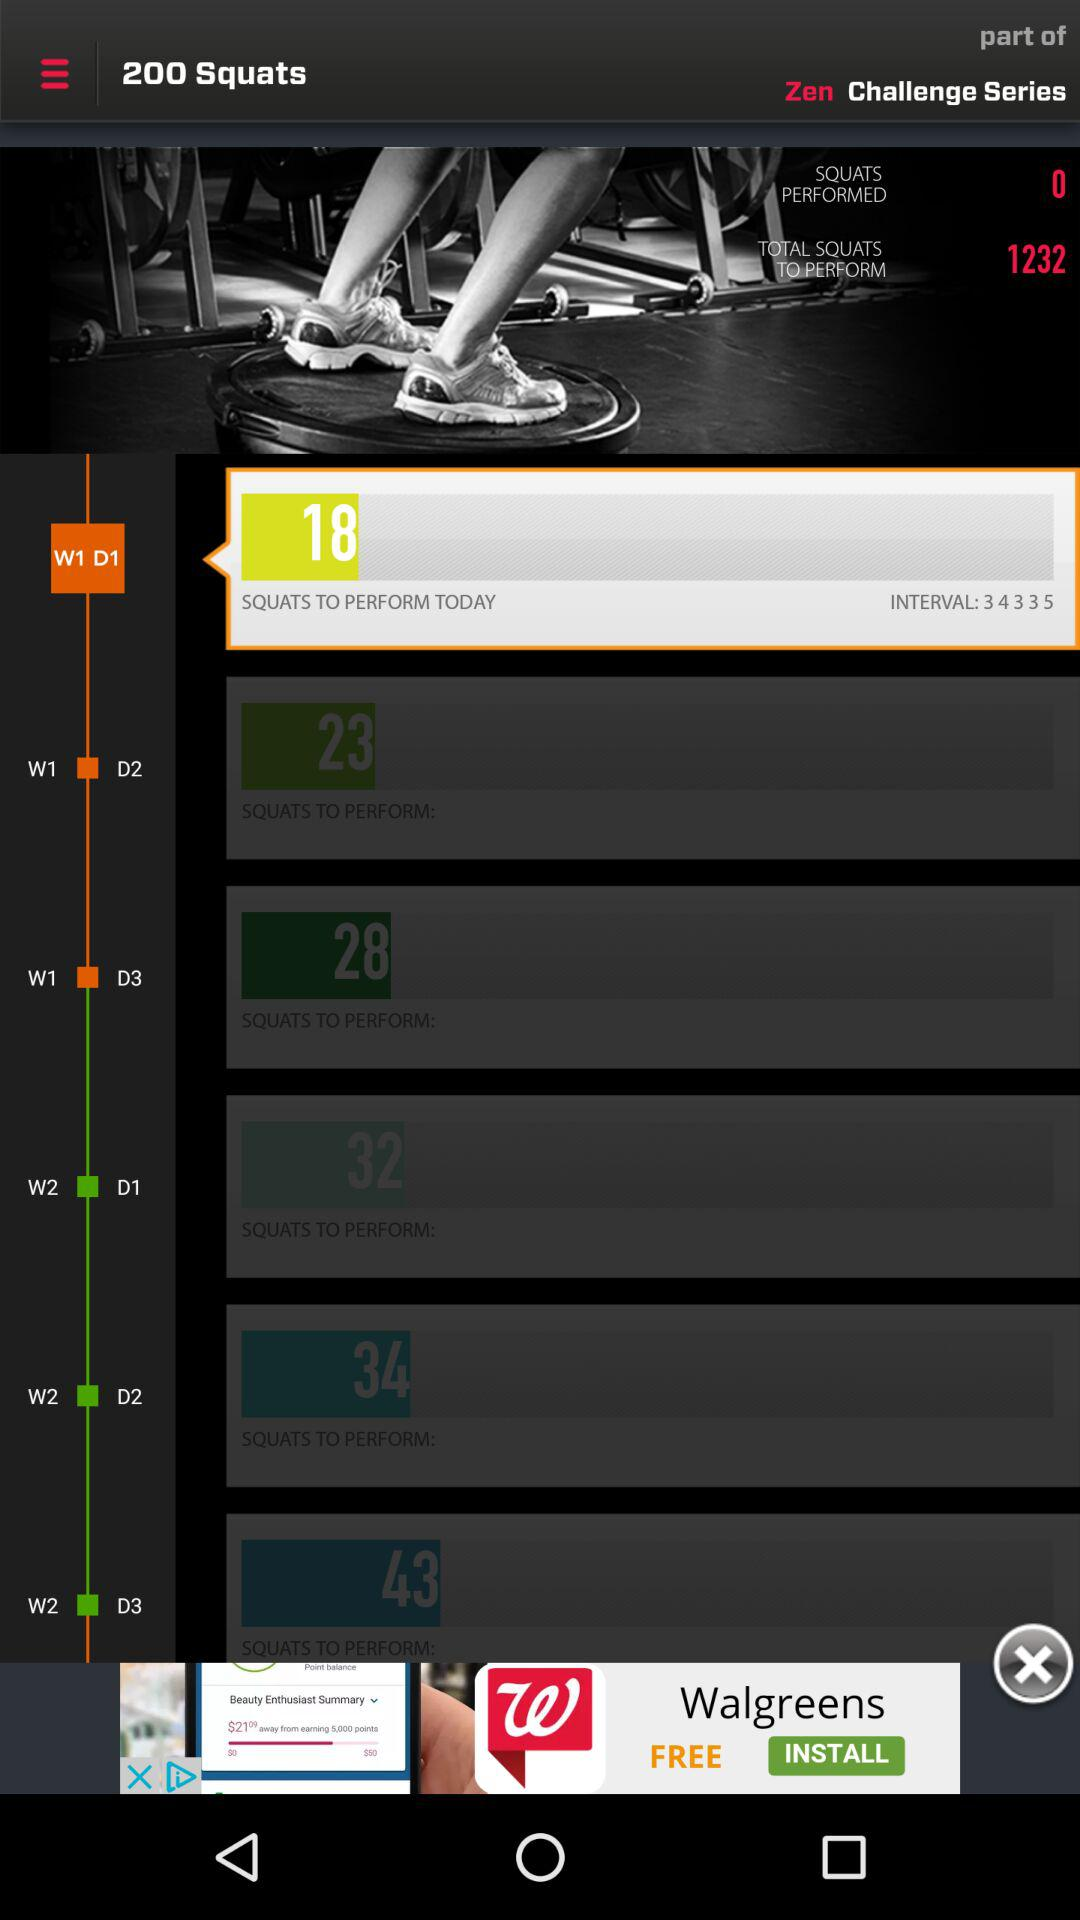How many squats in total are to be performed? There are 1232 squats that are to be performed. 